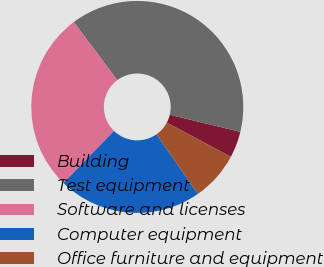Convert chart to OTSL. <chart><loc_0><loc_0><loc_500><loc_500><pie_chart><fcel>Building<fcel>Test equipment<fcel>Software and licenses<fcel>Computer equipment<fcel>Office furniture and equipment<nl><fcel>4.02%<fcel>39.0%<fcel>27.52%<fcel>21.94%<fcel>7.52%<nl></chart> 